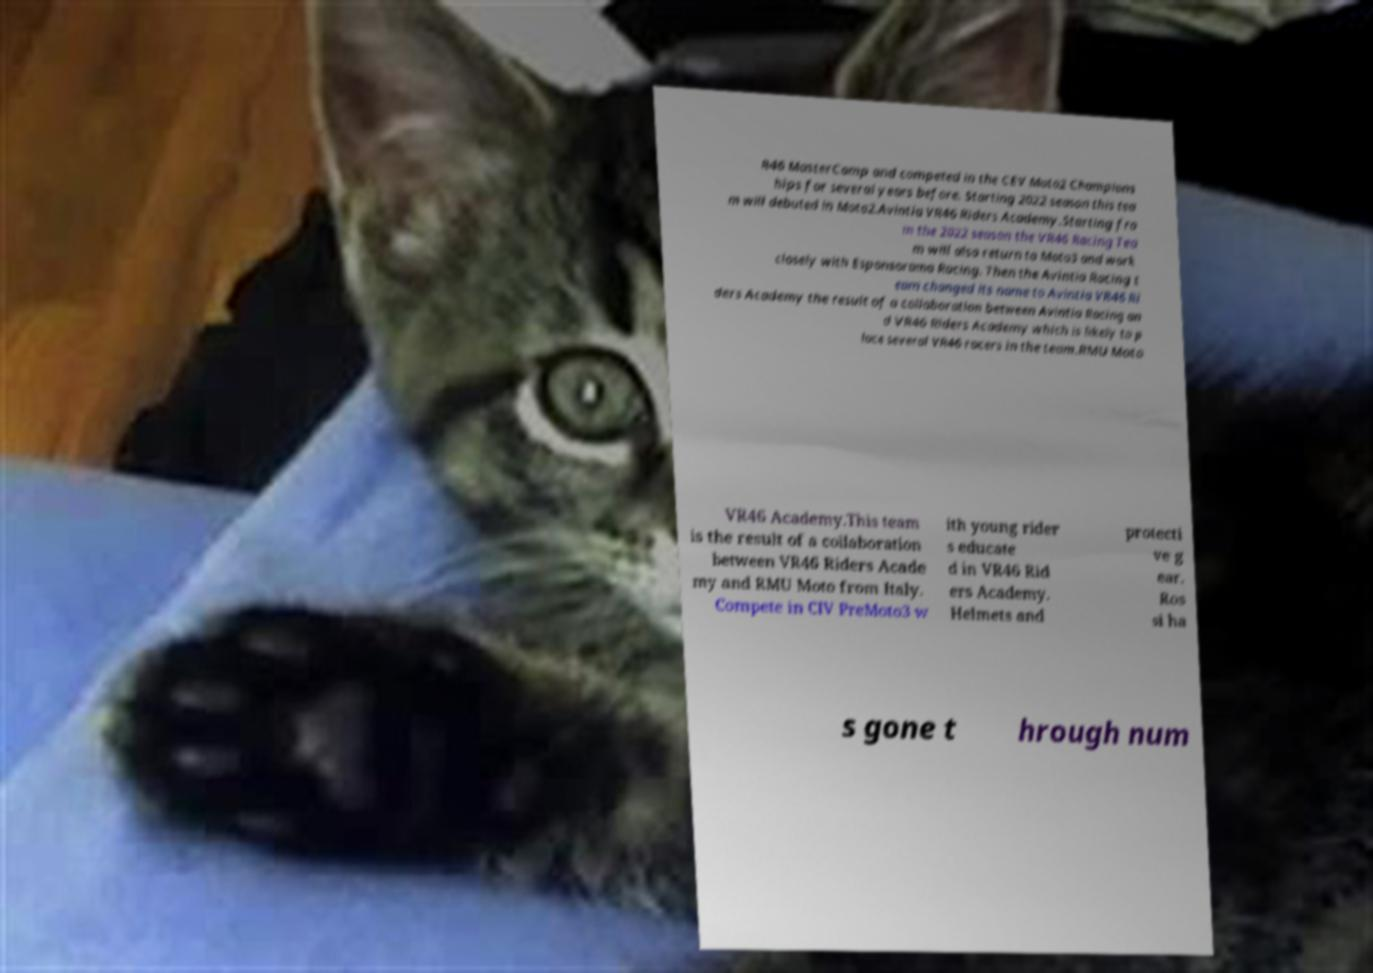For documentation purposes, I need the text within this image transcribed. Could you provide that? R46 MasterCamp and competed in the CEV Moto2 Champions hips for several years before. Starting 2022 season this tea m will debuted in Moto2.Avintia VR46 Riders Academy.Starting fro m the 2022 season the VR46 Racing Tea m will also return to Moto3 and work closely with Esponsorama Racing. Then the Avintia Racing t eam changed its name to Avintia VR46 Ri ders Academy the result of a collaboration between Avintia Racing an d VR46 Riders Academy which is likely to p lace several VR46 racers in the team.RMU Moto VR46 Academy.This team is the result of a collaboration between VR46 Riders Acade my and RMU Moto from Italy. Compete in CIV PreMoto3 w ith young rider s educate d in VR46 Rid ers Academy. Helmets and protecti ve g ear. Ros si ha s gone t hrough num 